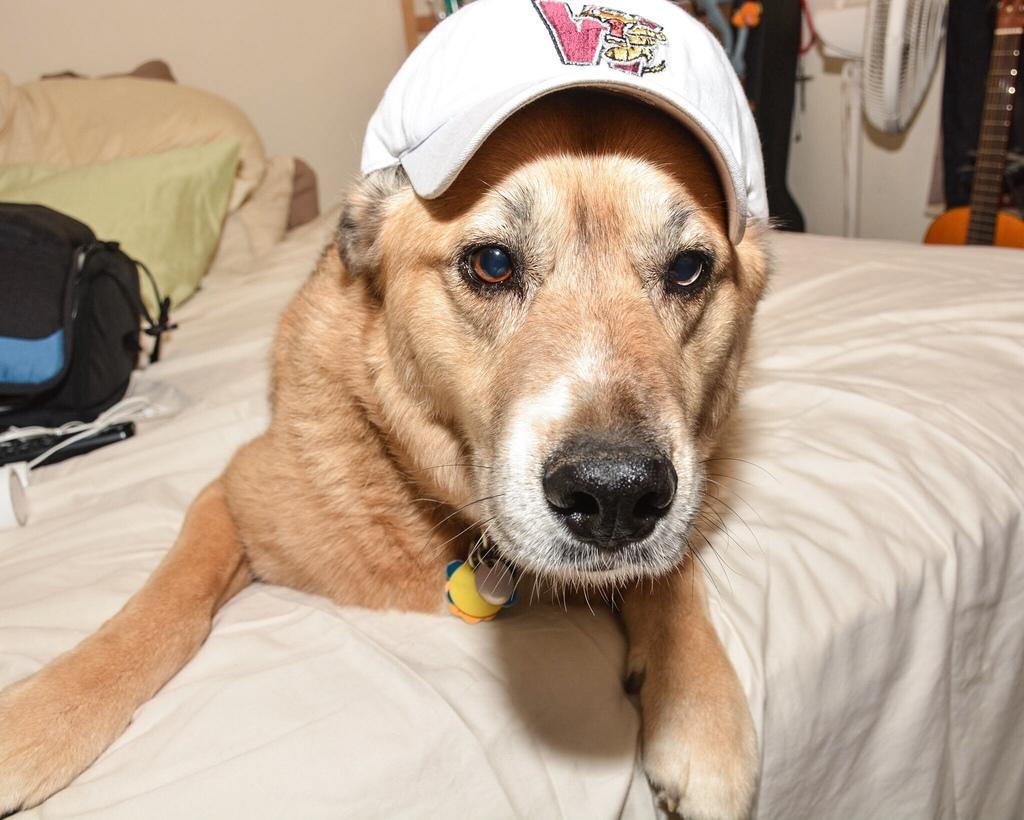Please provide a concise description of this image. In this image, dog is laying on the bed and wearing cap. Background we can see bag, few objects, table fan, guitar and wall. 